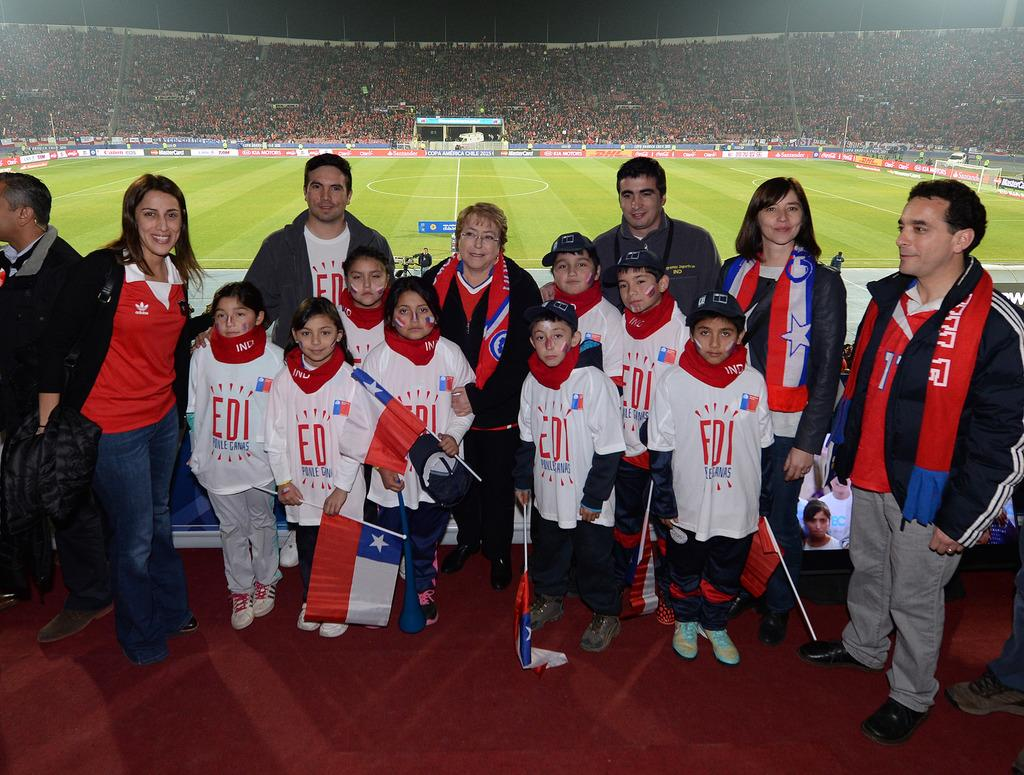<image>
Render a clear and concise summary of the photo. A group of kids in sports uniforms with the letters EDI on the jerseys standing with some adults. 